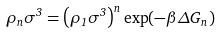<formula> <loc_0><loc_0><loc_500><loc_500>\rho _ { n } \sigma ^ { 3 } = \left ( \rho _ { 1 } \sigma ^ { 3 } \right ) ^ { n } \exp ( - \beta \Delta G _ { n } )</formula> 